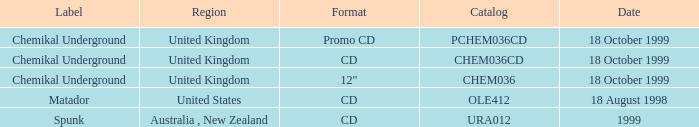What label is associated with the United Kingdom and the chem036 catalog? Chemikal Underground. Can you parse all the data within this table? {'header': ['Label', 'Region', 'Format', 'Catalog', 'Date'], 'rows': [['Chemikal Underground', 'United Kingdom', 'Promo CD', 'PCHEM036CD', '18 October 1999'], ['Chemikal Underground', 'United Kingdom', 'CD', 'CHEM036CD', '18 October 1999'], ['Chemikal Underground', 'United Kingdom', '12"', 'CHEM036', '18 October 1999'], ['Matador', 'United States', 'CD', 'OLE412', '18 August 1998'], ['Spunk', 'Australia , New Zealand', 'CD', 'URA012', '1999']]} 